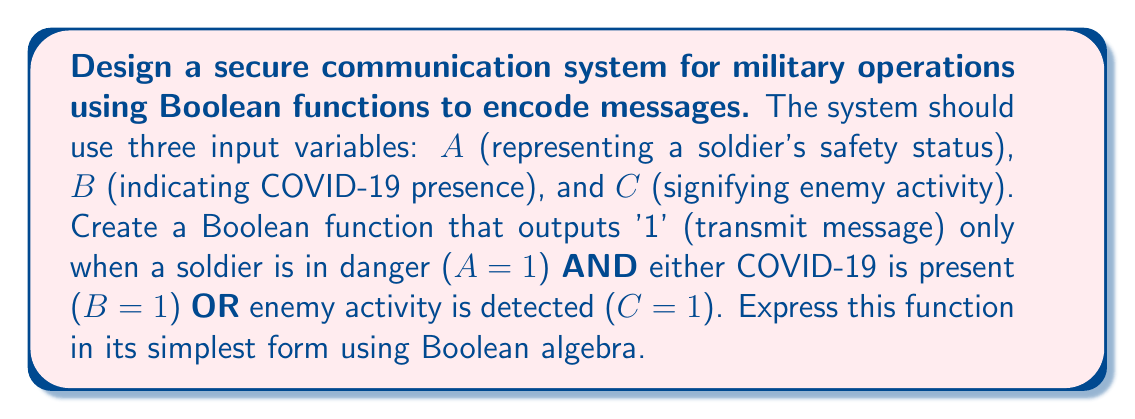Could you help me with this problem? Let's approach this step-by-step:

1) First, we need to translate the given conditions into a Boolean expression:
   - Soldier in danger: A = 1
   - COVID-19 present: B = 1
   - Enemy activity detected: C = 1
   - Transmit message when: A = 1 AND (B = 1 OR C = 1)

2) We can express this as a Boolean function:
   $$ F(A,B,C) = A \cdot (B + C) $$

3) This function is already in its simplest form, but let's verify using Boolean algebra laws:

   $$ F(A,B,C) = A \cdot (B + C) $$
   $$ = AB + AC $$ (Distributive Law)

4) We can verify that this simplified form is equivalent to our original requirements:
   - It will only output 1 when A = 1 (soldier in danger)
   - And when either B = 1 (COVID-19 present) or C = 1 (enemy activity)

5) Truth table verification:

   | A | B | C | F(A,B,C) |
   |---|---|---|----------|
   | 0 | 0 | 0 |    0     |
   | 0 | 0 | 1 |    0     |
   | 0 | 1 | 0 |    0     |
   | 0 | 1 | 1 |    0     |
   | 1 | 0 | 0 |    0     |
   | 1 | 0 | 1 |    1     |
   | 1 | 1 | 0 |    1     |
   | 1 | 1 | 1 |    1     |

This truth table confirms that our function meets the required conditions.
Answer: $F(A,B,C) = AB + AC$ 